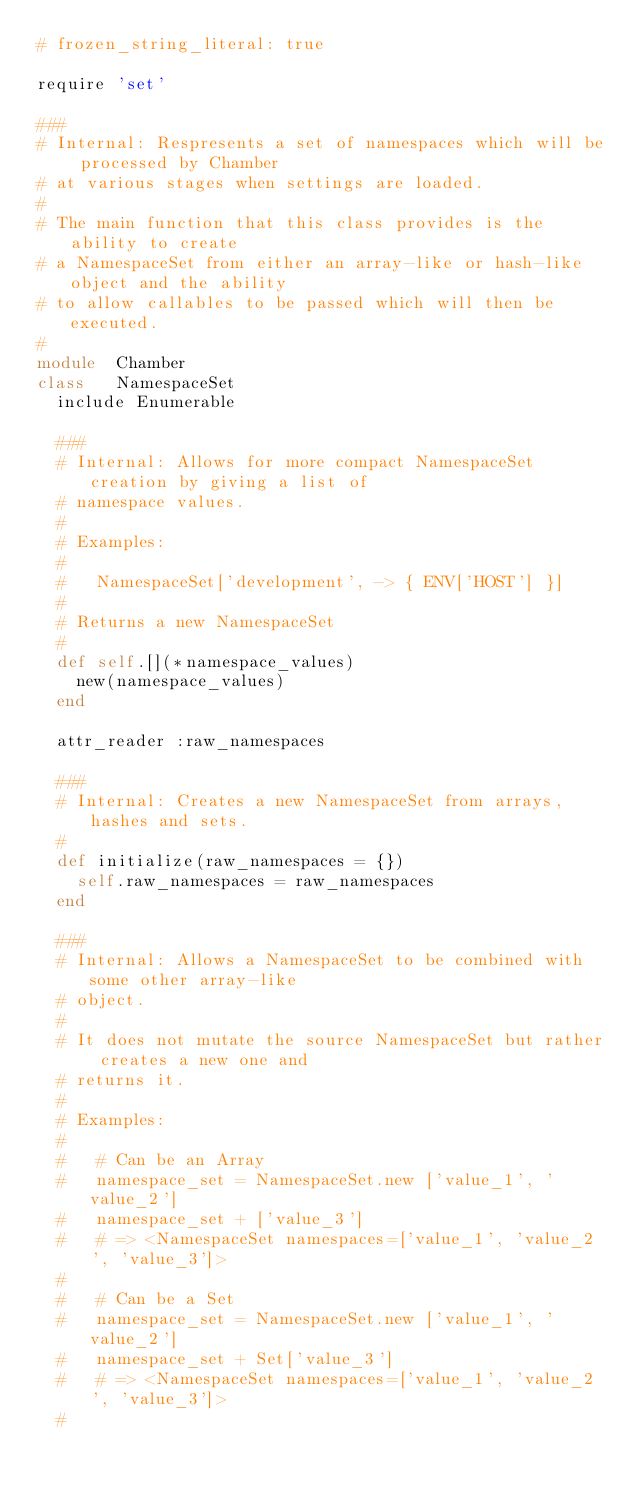<code> <loc_0><loc_0><loc_500><loc_500><_Ruby_># frozen_string_literal: true

require 'set'

###
# Internal: Respresents a set of namespaces which will be processed by Chamber
# at various stages when settings are loaded.
#
# The main function that this class provides is the ability to create
# a NamespaceSet from either an array-like or hash-like object and the ability
# to allow callables to be passed which will then be executed.
#
module  Chamber
class   NamespaceSet
  include Enumerable

  ###
  # Internal: Allows for more compact NamespaceSet creation by giving a list of
  # namespace values.
  #
  # Examples:
  #
  #   NamespaceSet['development', -> { ENV['HOST'] }]
  #
  # Returns a new NamespaceSet
  #
  def self.[](*namespace_values)
    new(namespace_values)
  end

  attr_reader :raw_namespaces

  ###
  # Internal: Creates a new NamespaceSet from arrays, hashes and sets.
  #
  def initialize(raw_namespaces = {})
    self.raw_namespaces = raw_namespaces
  end

  ###
  # Internal: Allows a NamespaceSet to be combined with some other array-like
  # object.
  #
  # It does not mutate the source NamespaceSet but rather creates a new one and
  # returns it.
  #
  # Examples:
  #
  #   # Can be an Array
  #   namespace_set = NamespaceSet.new ['value_1', 'value_2']
  #   namespace_set + ['value_3']
  #   # => <NamespaceSet namespaces=['value_1', 'value_2', 'value_3']>
  #
  #   # Can be a Set
  #   namespace_set = NamespaceSet.new ['value_1', 'value_2']
  #   namespace_set + Set['value_3']
  #   # => <NamespaceSet namespaces=['value_1', 'value_2', 'value_3']>
  #</code> 